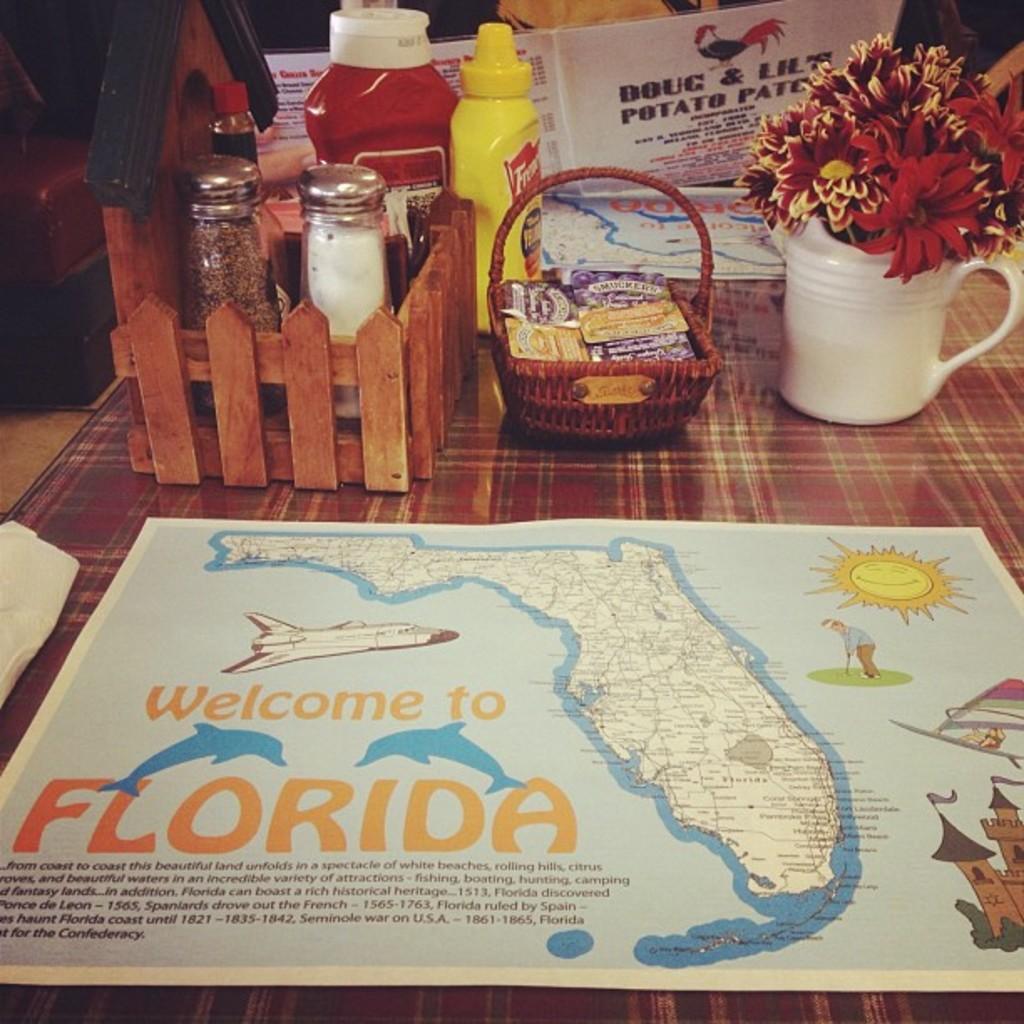Could you give a brief overview of what you see in this image? In this image I can see there is a table. On the table there is a stand with bottles and in that there are some food items. And there is a banner with logo and text. And there are some packets and a flower pot. And at the back it looks like a chair on the floor. 